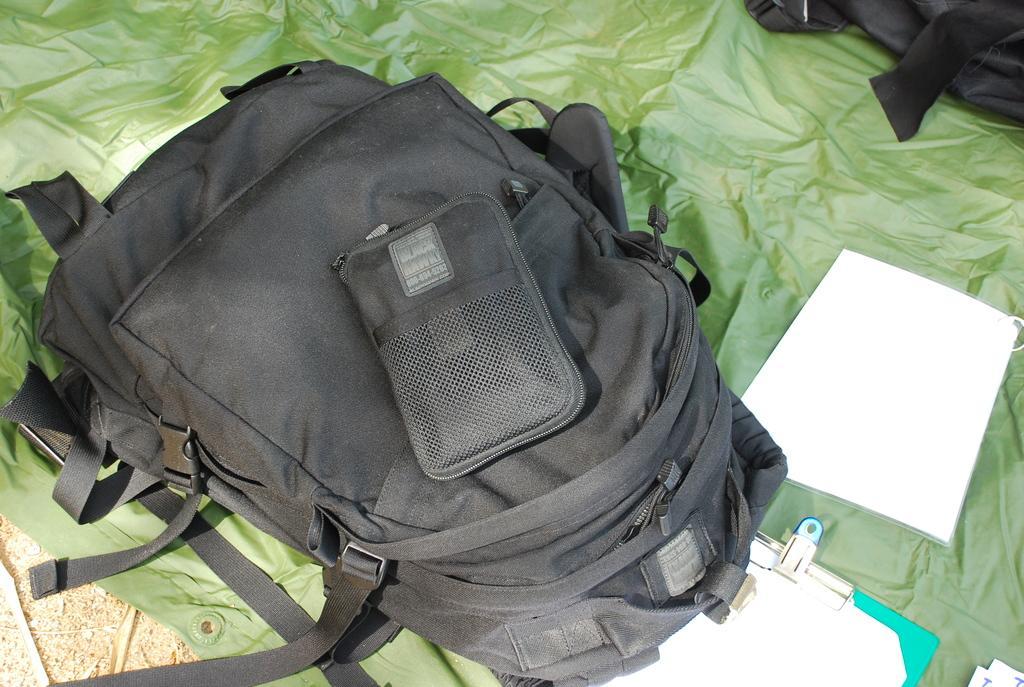Could you give a brief overview of what you see in this image? As we can see in the image there is a black color bag, paper, pad and a green color cloth. 